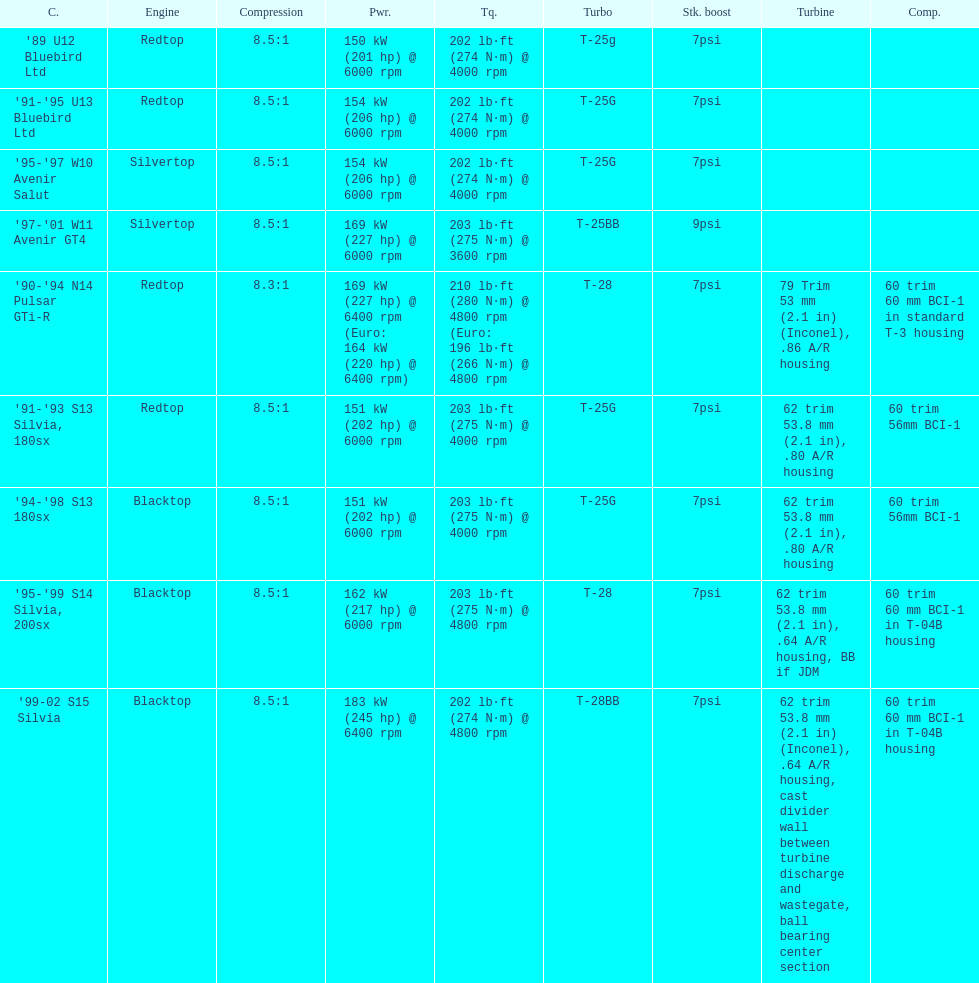How many models used the redtop engine? 4. Help me parse the entirety of this table. {'header': ['C.', 'Engine', 'Compression', 'Pwr.', 'Tq.', 'Turbo', 'Stk. boost', 'Turbine', 'Comp.'], 'rows': [["'89 U12 Bluebird Ltd", 'Redtop', '8.5:1', '150\xa0kW (201\xa0hp) @ 6000 rpm', '202\xa0lb·ft (274\xa0N·m) @ 4000 rpm', 'T-25g', '7psi', '', ''], ["'91-'95 U13 Bluebird Ltd", 'Redtop', '8.5:1', '154\xa0kW (206\xa0hp) @ 6000 rpm', '202\xa0lb·ft (274\xa0N·m) @ 4000 rpm', 'T-25G', '7psi', '', ''], ["'95-'97 W10 Avenir Salut", 'Silvertop', '8.5:1', '154\xa0kW (206\xa0hp) @ 6000 rpm', '202\xa0lb·ft (274\xa0N·m) @ 4000 rpm', 'T-25G', '7psi', '', ''], ["'97-'01 W11 Avenir GT4", 'Silvertop', '8.5:1', '169\xa0kW (227\xa0hp) @ 6000 rpm', '203\xa0lb·ft (275\xa0N·m) @ 3600 rpm', 'T-25BB', '9psi', '', ''], ["'90-'94 N14 Pulsar GTi-R", 'Redtop', '8.3:1', '169\xa0kW (227\xa0hp) @ 6400 rpm (Euro: 164\xa0kW (220\xa0hp) @ 6400 rpm)', '210\xa0lb·ft (280\xa0N·m) @ 4800 rpm (Euro: 196\xa0lb·ft (266\xa0N·m) @ 4800 rpm', 'T-28', '7psi', '79 Trim 53\xa0mm (2.1\xa0in) (Inconel), .86 A/R housing', '60 trim 60\xa0mm BCI-1 in standard T-3 housing'], ["'91-'93 S13 Silvia, 180sx", 'Redtop', '8.5:1', '151\xa0kW (202\xa0hp) @ 6000 rpm', '203\xa0lb·ft (275\xa0N·m) @ 4000 rpm', 'T-25G', '7psi', '62 trim 53.8\xa0mm (2.1\xa0in), .80 A/R housing', '60 trim 56mm BCI-1'], ["'94-'98 S13 180sx", 'Blacktop', '8.5:1', '151\xa0kW (202\xa0hp) @ 6000 rpm', '203\xa0lb·ft (275\xa0N·m) @ 4000 rpm', 'T-25G', '7psi', '62 trim 53.8\xa0mm (2.1\xa0in), .80 A/R housing', '60 trim 56mm BCI-1'], ["'95-'99 S14 Silvia, 200sx", 'Blacktop', '8.5:1', '162\xa0kW (217\xa0hp) @ 6000 rpm', '203\xa0lb·ft (275\xa0N·m) @ 4800 rpm', 'T-28', '7psi', '62 trim 53.8\xa0mm (2.1\xa0in), .64 A/R housing, BB if JDM', '60 trim 60\xa0mm BCI-1 in T-04B housing'], ["'99-02 S15 Silvia", 'Blacktop', '8.5:1', '183\xa0kW (245\xa0hp) @ 6400 rpm', '202\xa0lb·ft (274\xa0N·m) @ 4800 rpm', 'T-28BB', '7psi', '62 trim 53.8\xa0mm (2.1\xa0in) (Inconel), .64 A/R housing, cast divider wall between turbine discharge and wastegate, ball bearing center section', '60 trim 60\xa0mm BCI-1 in T-04B housing']]} 